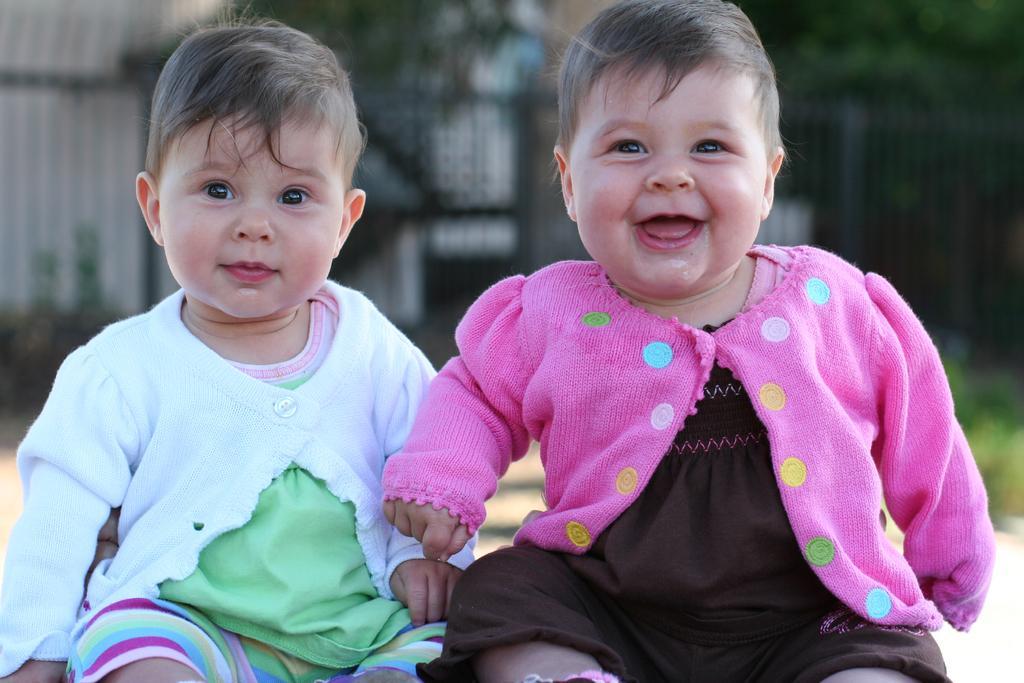Please provide a concise description of this image. Baby in the black dress and pink jacket is sitting and she is smiling. Beside her, the baby in green t-shirt and white jacket is also sitting and she is also smiling. Behind them, we see buildings and trees and we even see grass. It is blurred in the background. 